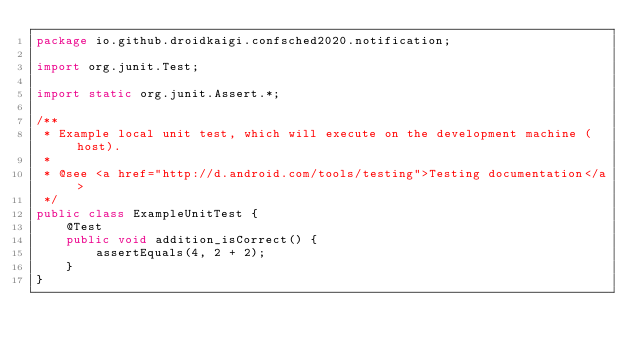Convert code to text. <code><loc_0><loc_0><loc_500><loc_500><_Java_>package io.github.droidkaigi.confsched2020.notification;

import org.junit.Test;

import static org.junit.Assert.*;

/**
 * Example local unit test, which will execute on the development machine (host).
 *
 * @see <a href="http://d.android.com/tools/testing">Testing documentation</a>
 */
public class ExampleUnitTest {
    @Test
    public void addition_isCorrect() {
        assertEquals(4, 2 + 2);
    }
}
</code> 